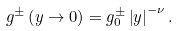<formula> <loc_0><loc_0><loc_500><loc_500>g ^ { \pm } \left ( y \rightarrow 0 \right ) = g _ { 0 } ^ { \pm } \left | y \right | ^ { - \nu } .</formula> 